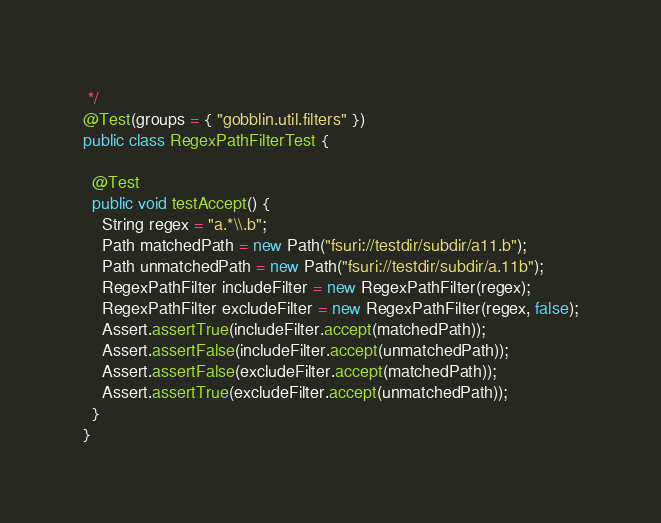Convert code to text. <code><loc_0><loc_0><loc_500><loc_500><_Java_> */
@Test(groups = { "gobblin.util.filters" })
public class RegexPathFilterTest {

  @Test
  public void testAccept() {
    String regex = "a.*\\.b";
    Path matchedPath = new Path("fsuri://testdir/subdir/a11.b");
    Path unmatchedPath = new Path("fsuri://testdir/subdir/a.11b");
    RegexPathFilter includeFilter = new RegexPathFilter(regex);
    RegexPathFilter excludeFilter = new RegexPathFilter(regex, false);
    Assert.assertTrue(includeFilter.accept(matchedPath));
    Assert.assertFalse(includeFilter.accept(unmatchedPath));
    Assert.assertFalse(excludeFilter.accept(matchedPath));
    Assert.assertTrue(excludeFilter.accept(unmatchedPath));
  }
}</code> 